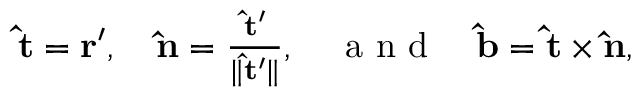Convert formula to latex. <formula><loc_0><loc_0><loc_500><loc_500>\begin{array} { r } { \hat { t } = r ^ { \prime } , \quad \hat { n } = \frac { \hat { t } ^ { \prime } } { \| \hat { t } ^ { \prime } \| } , \quad a n d \quad \hat { b } = \hat { t } \times \hat { n } , } \end{array}</formula> 